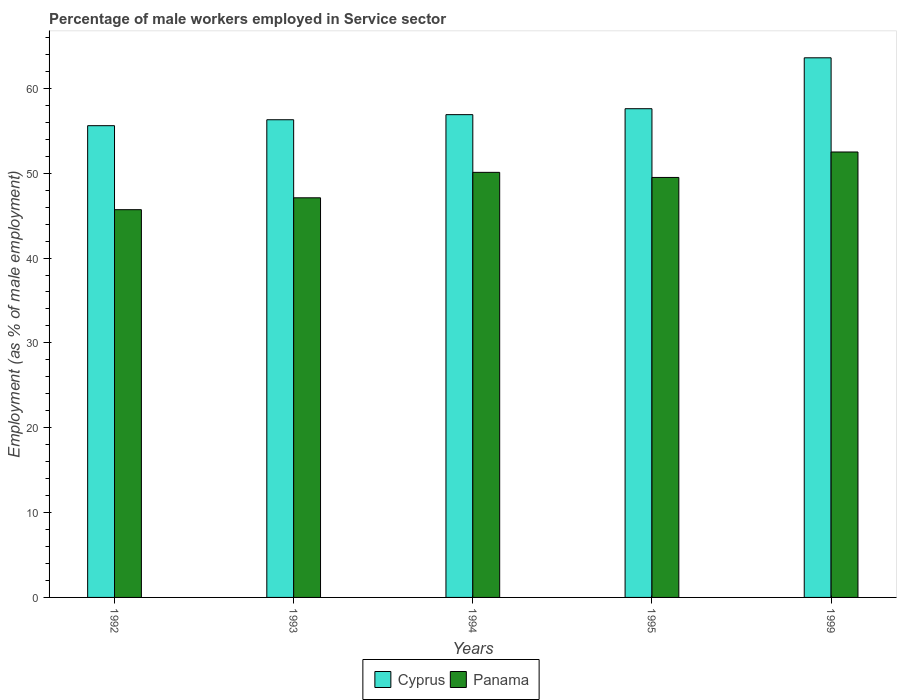How many different coloured bars are there?
Your response must be concise. 2. Are the number of bars on each tick of the X-axis equal?
Provide a succinct answer. Yes. What is the percentage of male workers employed in Service sector in Cyprus in 1994?
Provide a short and direct response. 56.9. Across all years, what is the maximum percentage of male workers employed in Service sector in Cyprus?
Offer a terse response. 63.6. Across all years, what is the minimum percentage of male workers employed in Service sector in Panama?
Your answer should be compact. 45.7. In which year was the percentage of male workers employed in Service sector in Cyprus maximum?
Give a very brief answer. 1999. What is the total percentage of male workers employed in Service sector in Panama in the graph?
Provide a succinct answer. 244.9. What is the difference between the percentage of male workers employed in Service sector in Panama in 1992 and that in 1995?
Your response must be concise. -3.8. What is the average percentage of male workers employed in Service sector in Panama per year?
Provide a succinct answer. 48.98. In the year 1993, what is the difference between the percentage of male workers employed in Service sector in Cyprus and percentage of male workers employed in Service sector in Panama?
Your answer should be very brief. 9.2. What is the ratio of the percentage of male workers employed in Service sector in Panama in 1993 to that in 1994?
Ensure brevity in your answer.  0.94. What is the difference between the highest and the second highest percentage of male workers employed in Service sector in Panama?
Your answer should be very brief. 2.4. What is the difference between the highest and the lowest percentage of male workers employed in Service sector in Panama?
Give a very brief answer. 6.8. What does the 2nd bar from the left in 1992 represents?
Keep it short and to the point. Panama. What does the 1st bar from the right in 1995 represents?
Keep it short and to the point. Panama. Are all the bars in the graph horizontal?
Give a very brief answer. No. Where does the legend appear in the graph?
Keep it short and to the point. Bottom center. What is the title of the graph?
Your answer should be very brief. Percentage of male workers employed in Service sector. Does "Macao" appear as one of the legend labels in the graph?
Your answer should be compact. No. What is the label or title of the X-axis?
Ensure brevity in your answer.  Years. What is the label or title of the Y-axis?
Provide a short and direct response. Employment (as % of male employment). What is the Employment (as % of male employment) of Cyprus in 1992?
Your answer should be very brief. 55.6. What is the Employment (as % of male employment) in Panama in 1992?
Make the answer very short. 45.7. What is the Employment (as % of male employment) in Cyprus in 1993?
Offer a terse response. 56.3. What is the Employment (as % of male employment) in Panama in 1993?
Offer a very short reply. 47.1. What is the Employment (as % of male employment) of Cyprus in 1994?
Your answer should be very brief. 56.9. What is the Employment (as % of male employment) of Panama in 1994?
Give a very brief answer. 50.1. What is the Employment (as % of male employment) of Cyprus in 1995?
Give a very brief answer. 57.6. What is the Employment (as % of male employment) of Panama in 1995?
Offer a terse response. 49.5. What is the Employment (as % of male employment) in Cyprus in 1999?
Make the answer very short. 63.6. What is the Employment (as % of male employment) in Panama in 1999?
Make the answer very short. 52.5. Across all years, what is the maximum Employment (as % of male employment) in Cyprus?
Offer a very short reply. 63.6. Across all years, what is the maximum Employment (as % of male employment) in Panama?
Ensure brevity in your answer.  52.5. Across all years, what is the minimum Employment (as % of male employment) in Cyprus?
Ensure brevity in your answer.  55.6. Across all years, what is the minimum Employment (as % of male employment) of Panama?
Your response must be concise. 45.7. What is the total Employment (as % of male employment) in Cyprus in the graph?
Your answer should be very brief. 290. What is the total Employment (as % of male employment) of Panama in the graph?
Your response must be concise. 244.9. What is the difference between the Employment (as % of male employment) of Cyprus in 1992 and that in 1993?
Ensure brevity in your answer.  -0.7. What is the difference between the Employment (as % of male employment) in Panama in 1992 and that in 1993?
Offer a very short reply. -1.4. What is the difference between the Employment (as % of male employment) in Cyprus in 1992 and that in 1994?
Your response must be concise. -1.3. What is the difference between the Employment (as % of male employment) in Panama in 1992 and that in 1994?
Your answer should be very brief. -4.4. What is the difference between the Employment (as % of male employment) of Cyprus in 1992 and that in 1995?
Ensure brevity in your answer.  -2. What is the difference between the Employment (as % of male employment) in Panama in 1992 and that in 1995?
Your answer should be very brief. -3.8. What is the difference between the Employment (as % of male employment) of Panama in 1993 and that in 1995?
Ensure brevity in your answer.  -2.4. What is the difference between the Employment (as % of male employment) of Cyprus in 1993 and that in 1999?
Your answer should be compact. -7.3. What is the difference between the Employment (as % of male employment) of Panama in 1994 and that in 1999?
Provide a short and direct response. -2.4. What is the difference between the Employment (as % of male employment) in Panama in 1995 and that in 1999?
Your answer should be very brief. -3. What is the difference between the Employment (as % of male employment) in Cyprus in 1992 and the Employment (as % of male employment) in Panama in 1999?
Ensure brevity in your answer.  3.1. What is the difference between the Employment (as % of male employment) in Cyprus in 1993 and the Employment (as % of male employment) in Panama in 1995?
Ensure brevity in your answer.  6.8. What is the average Employment (as % of male employment) of Cyprus per year?
Make the answer very short. 58. What is the average Employment (as % of male employment) in Panama per year?
Provide a short and direct response. 48.98. In the year 1994, what is the difference between the Employment (as % of male employment) of Cyprus and Employment (as % of male employment) of Panama?
Your answer should be very brief. 6.8. In the year 1995, what is the difference between the Employment (as % of male employment) of Cyprus and Employment (as % of male employment) of Panama?
Offer a very short reply. 8.1. What is the ratio of the Employment (as % of male employment) in Cyprus in 1992 to that in 1993?
Your answer should be very brief. 0.99. What is the ratio of the Employment (as % of male employment) of Panama in 1992 to that in 1993?
Your answer should be very brief. 0.97. What is the ratio of the Employment (as % of male employment) in Cyprus in 1992 to that in 1994?
Ensure brevity in your answer.  0.98. What is the ratio of the Employment (as % of male employment) in Panama in 1992 to that in 1994?
Offer a terse response. 0.91. What is the ratio of the Employment (as % of male employment) in Cyprus in 1992 to that in 1995?
Offer a terse response. 0.97. What is the ratio of the Employment (as % of male employment) of Panama in 1992 to that in 1995?
Give a very brief answer. 0.92. What is the ratio of the Employment (as % of male employment) of Cyprus in 1992 to that in 1999?
Make the answer very short. 0.87. What is the ratio of the Employment (as % of male employment) in Panama in 1992 to that in 1999?
Keep it short and to the point. 0.87. What is the ratio of the Employment (as % of male employment) in Cyprus in 1993 to that in 1994?
Offer a very short reply. 0.99. What is the ratio of the Employment (as % of male employment) in Panama in 1993 to that in 1994?
Your answer should be compact. 0.94. What is the ratio of the Employment (as % of male employment) of Cyprus in 1993 to that in 1995?
Give a very brief answer. 0.98. What is the ratio of the Employment (as % of male employment) of Panama in 1993 to that in 1995?
Make the answer very short. 0.95. What is the ratio of the Employment (as % of male employment) of Cyprus in 1993 to that in 1999?
Give a very brief answer. 0.89. What is the ratio of the Employment (as % of male employment) of Panama in 1993 to that in 1999?
Keep it short and to the point. 0.9. What is the ratio of the Employment (as % of male employment) of Panama in 1994 to that in 1995?
Give a very brief answer. 1.01. What is the ratio of the Employment (as % of male employment) in Cyprus in 1994 to that in 1999?
Provide a short and direct response. 0.89. What is the ratio of the Employment (as % of male employment) of Panama in 1994 to that in 1999?
Provide a succinct answer. 0.95. What is the ratio of the Employment (as % of male employment) in Cyprus in 1995 to that in 1999?
Provide a short and direct response. 0.91. What is the ratio of the Employment (as % of male employment) in Panama in 1995 to that in 1999?
Your response must be concise. 0.94. What is the difference between the highest and the second highest Employment (as % of male employment) in Cyprus?
Ensure brevity in your answer.  6. What is the difference between the highest and the lowest Employment (as % of male employment) of Panama?
Keep it short and to the point. 6.8. 